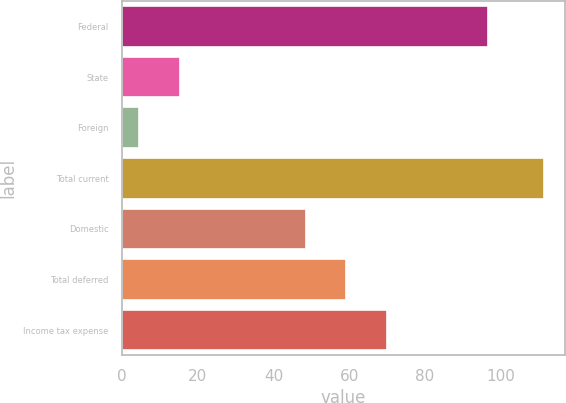Convert chart to OTSL. <chart><loc_0><loc_0><loc_500><loc_500><bar_chart><fcel>Federal<fcel>State<fcel>Foreign<fcel>Total current<fcel>Domestic<fcel>Total deferred<fcel>Income tax expense<nl><fcel>96.7<fcel>15.28<fcel>4.6<fcel>111.4<fcel>48.6<fcel>59.28<fcel>69.96<nl></chart> 